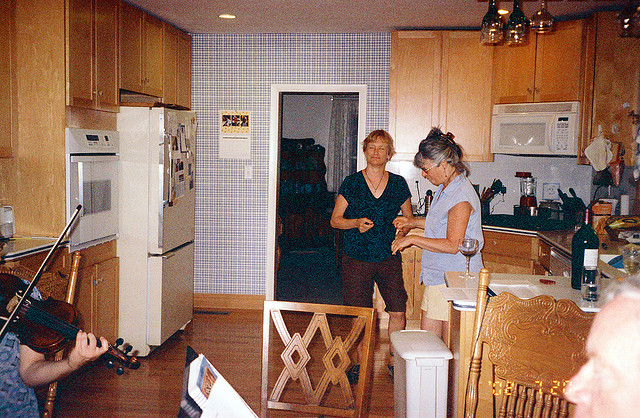What might be the occasion here? While the specific occasion is not clear from the photo alone, the combination of music, relaxed attire, and what appears to be refreshments on the kitchen island hints at a casual social gathering, possibly a family get-together, a small party among friends, or an intimate musical evening. 